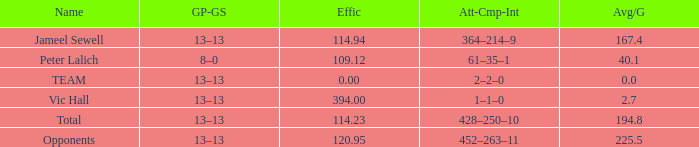Avg/G smaller than 225.5, and a GP-GS of 8–0 has what name? Peter Lalich. 